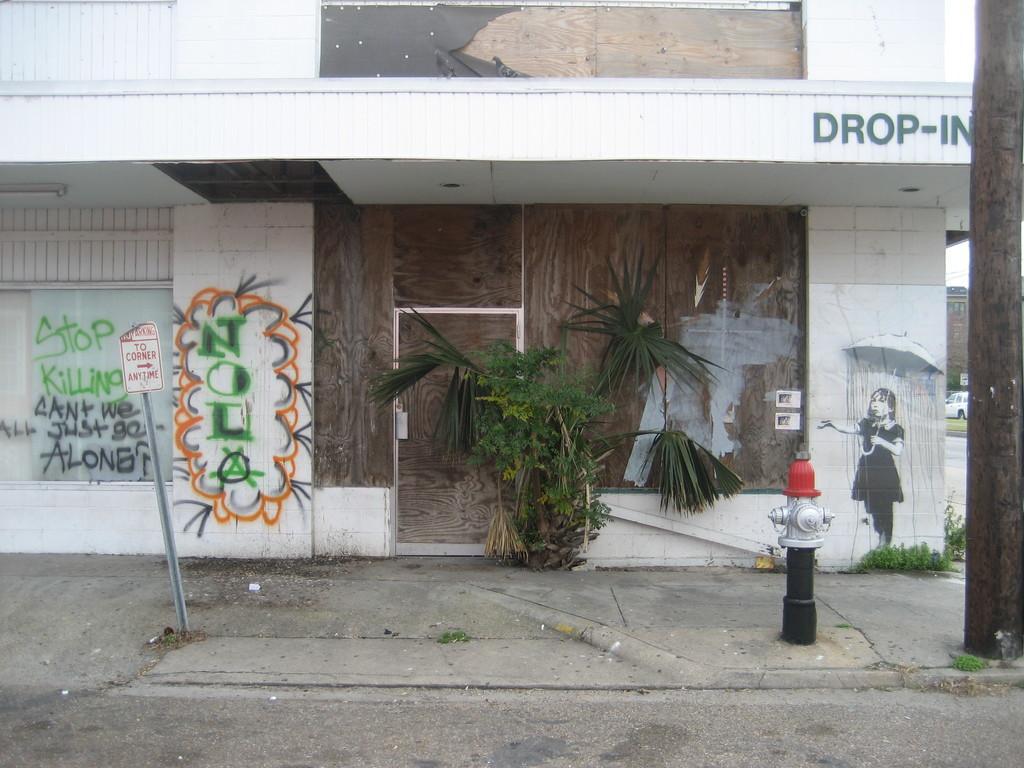Can you describe this image briefly? In the picture I can see the building. I can see the trunk of a tree on the right side. There is a fire hydrant on the right side. I can see the text painting on the wall and there is a painting of a woman holding an umbrella on the wall on the right side. There is a caution board pole on the left side. 